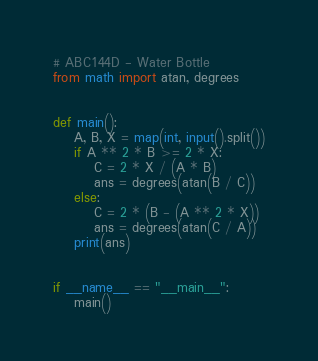Convert code to text. <code><loc_0><loc_0><loc_500><loc_500><_Python_># ABC144D - Water Bottle
from math import atan, degrees


def main():
    A, B, X = map(int, input().split())
    if A ** 2 * B >= 2 * X:
        C = 2 * X / (A * B)
        ans = degrees(atan(B / C))
    else:
        C = 2 * (B - (A ** 2 * X))
        ans = degrees(atan(C / A))
    print(ans)


if __name__ == "__main__":
    main()</code> 